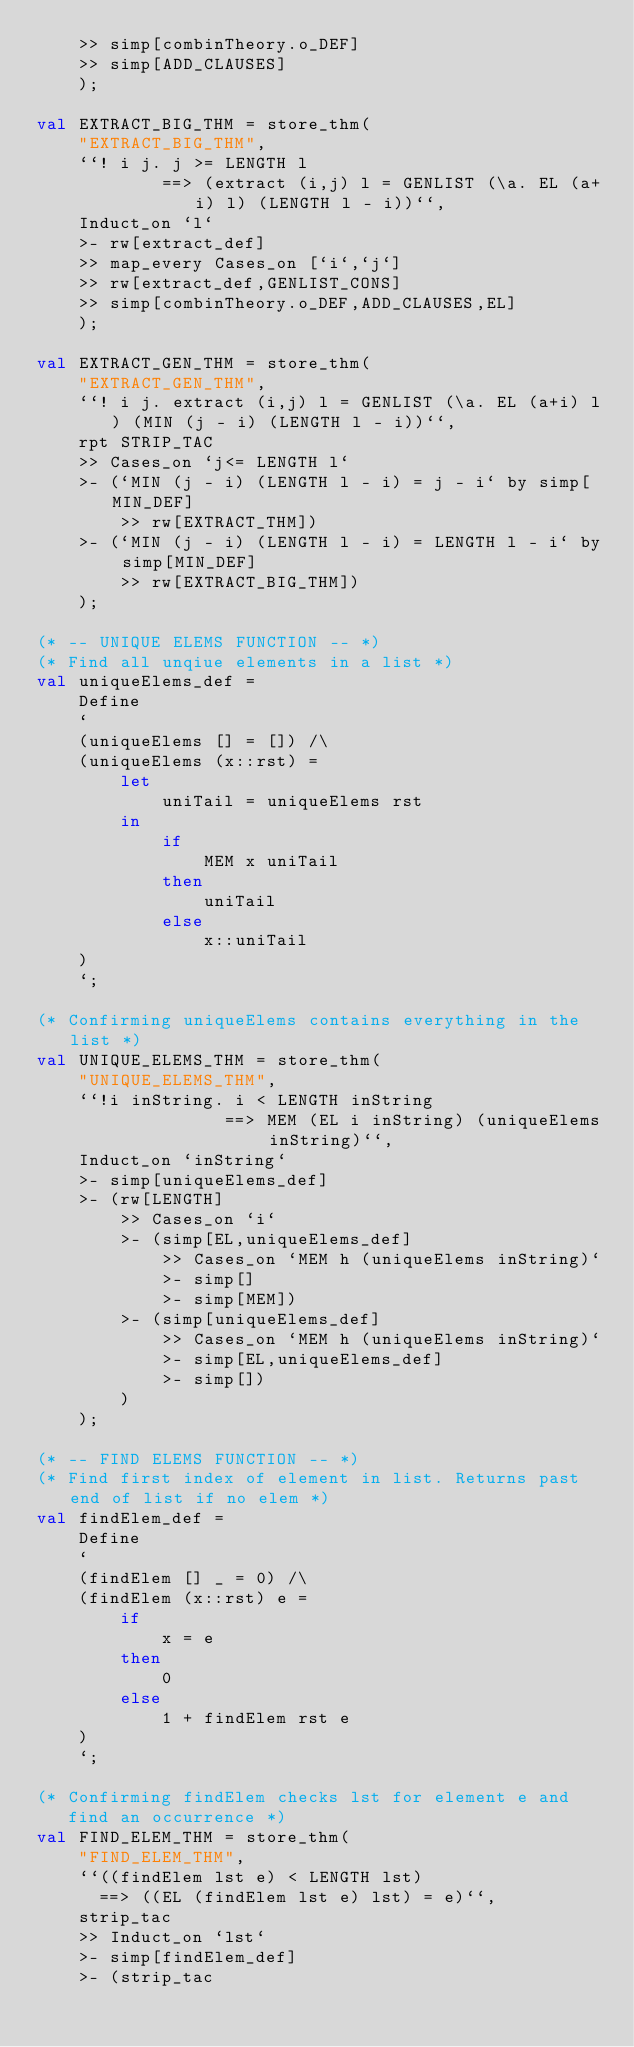<code> <loc_0><loc_0><loc_500><loc_500><_SML_>    >> simp[combinTheory.o_DEF]
    >> simp[ADD_CLAUSES]
    );

val EXTRACT_BIG_THM = store_thm(
    "EXTRACT_BIG_THM",
    ``! i j. j >= LENGTH l
            ==> (extract (i,j) l = GENLIST (\a. EL (a+i) l) (LENGTH l - i))``,
    Induct_on `l`
    >- rw[extract_def]
    >> map_every Cases_on [`i`,`j`]
    >> rw[extract_def,GENLIST_CONS]
    >> simp[combinTheory.o_DEF,ADD_CLAUSES,EL]
    );

val EXTRACT_GEN_THM = store_thm(
    "EXTRACT_GEN_THM",
    ``! i j. extract (i,j) l = GENLIST (\a. EL (a+i) l) (MIN (j - i) (LENGTH l - i))``,
    rpt STRIP_TAC
    >> Cases_on `j<= LENGTH l`
    >- (`MIN (j - i) (LENGTH l - i) = j - i` by simp[MIN_DEF]
        >> rw[EXTRACT_THM])
    >- (`MIN (j - i) (LENGTH l - i) = LENGTH l - i` by simp[MIN_DEF]
        >> rw[EXTRACT_BIG_THM])
    );

(* -- UNIQUE ELEMS FUNCTION -- *)
(* Find all unqiue elements in a list *)
val uniqueElems_def =
    Define
    `
    (uniqueElems [] = []) /\
    (uniqueElems (x::rst) =
        let
            uniTail = uniqueElems rst
        in
            if
                MEM x uniTail
            then
                uniTail
            else
                x::uniTail
    )
    `;

(* Confirming uniqueElems contains everything in the list *)
val UNIQUE_ELEMS_THM = store_thm(
    "UNIQUE_ELEMS_THM",
    ``!i inString. i < LENGTH inString
                  ==> MEM (EL i inString) (uniqueElems inString)``,
    Induct_on `inString`
    >- simp[uniqueElems_def]
    >- (rw[LENGTH]
        >> Cases_on `i`
        >- (simp[EL,uniqueElems_def]
            >> Cases_on `MEM h (uniqueElems inString)`
            >- simp[]
            >- simp[MEM])
        >- (simp[uniqueElems_def]
            >> Cases_on `MEM h (uniqueElems inString)`
            >- simp[EL,uniqueElems_def]
            >- simp[])
        )
    );

(* -- FIND ELEMS FUNCTION -- *)
(* Find first index of element in list. Returns past end of list if no elem *)
val findElem_def =
    Define
    `
    (findElem [] _ = 0) /\
    (findElem (x::rst) e =
        if
            x = e
        then
            0
        else
            1 + findElem rst e
    )
    `;

(* Confirming findElem checks lst for element e and
   find an occurrence *)
val FIND_ELEM_THM = store_thm(
    "FIND_ELEM_THM",
    ``((findElem lst e) < LENGTH lst)
      ==> ((EL (findElem lst e) lst) = e)``,
    strip_tac
    >> Induct_on `lst`
    >- simp[findElem_def]
    >- (strip_tac</code> 